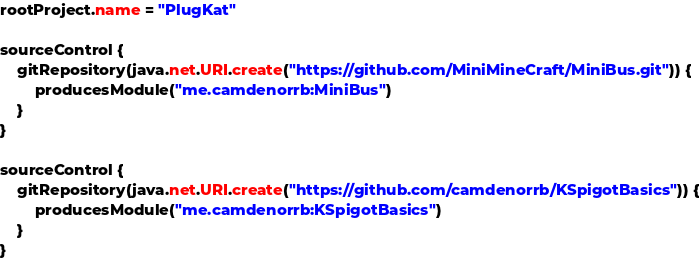Convert code to text. <code><loc_0><loc_0><loc_500><loc_500><_Kotlin_>rootProject.name = "PlugKat"

sourceControl {
	gitRepository(java.net.URI.create("https://github.com/MiniMineCraft/MiniBus.git")) {
		producesModule("me.camdenorrb:MiniBus")
	}
}

sourceControl {
	gitRepository(java.net.URI.create("https://github.com/camdenorrb/KSpigotBasics")) {
		producesModule("me.camdenorrb:KSpigotBasics")
	}
}</code> 